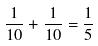<formula> <loc_0><loc_0><loc_500><loc_500>\frac { 1 } { 1 0 } + \frac { 1 } { 1 0 } = \frac { 1 } { 5 }</formula> 